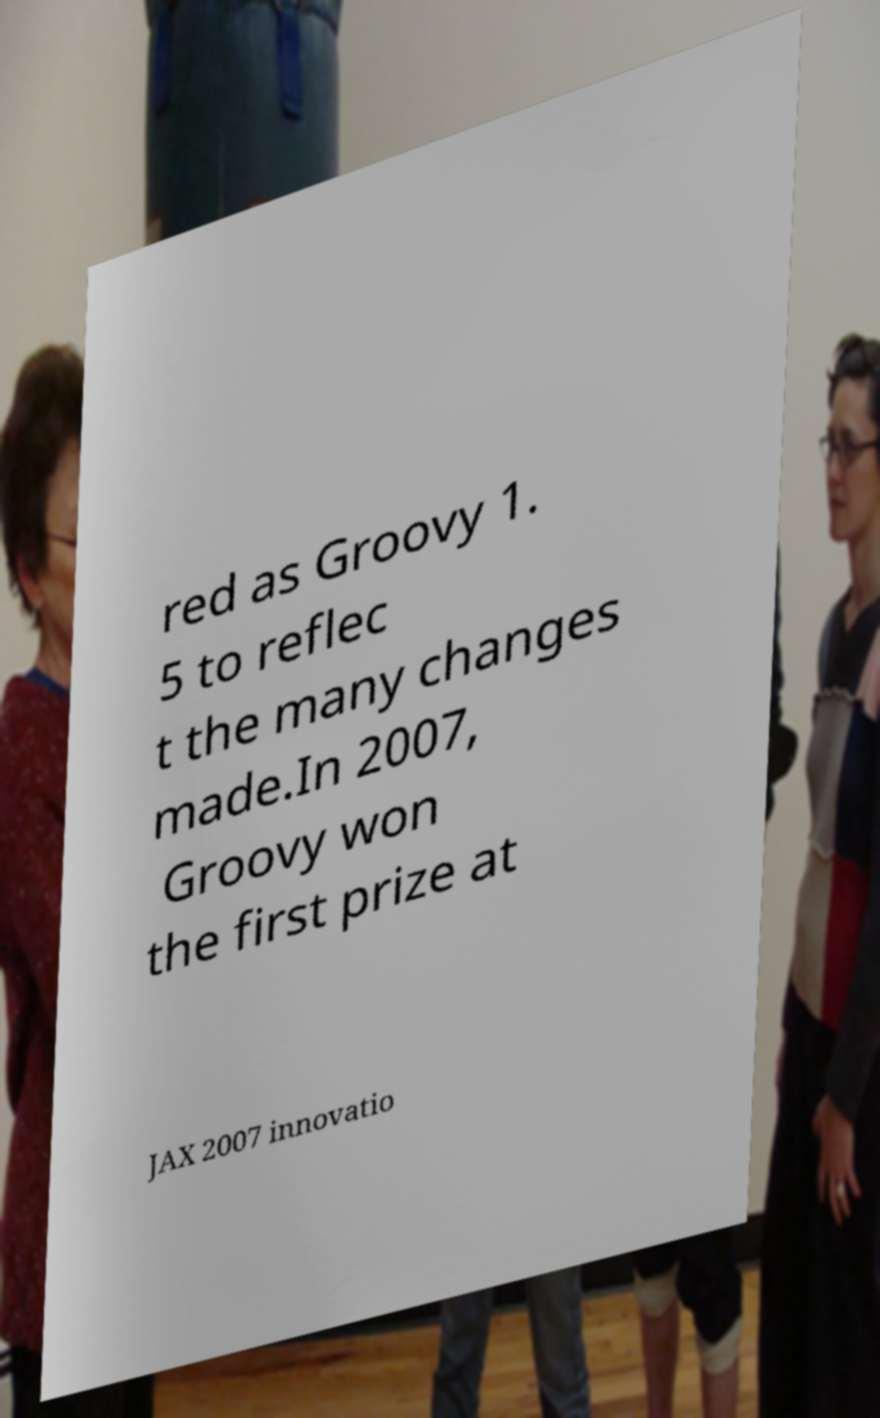There's text embedded in this image that I need extracted. Can you transcribe it verbatim? red as Groovy 1. 5 to reflec t the many changes made.In 2007, Groovy won the first prize at JAX 2007 innovatio 